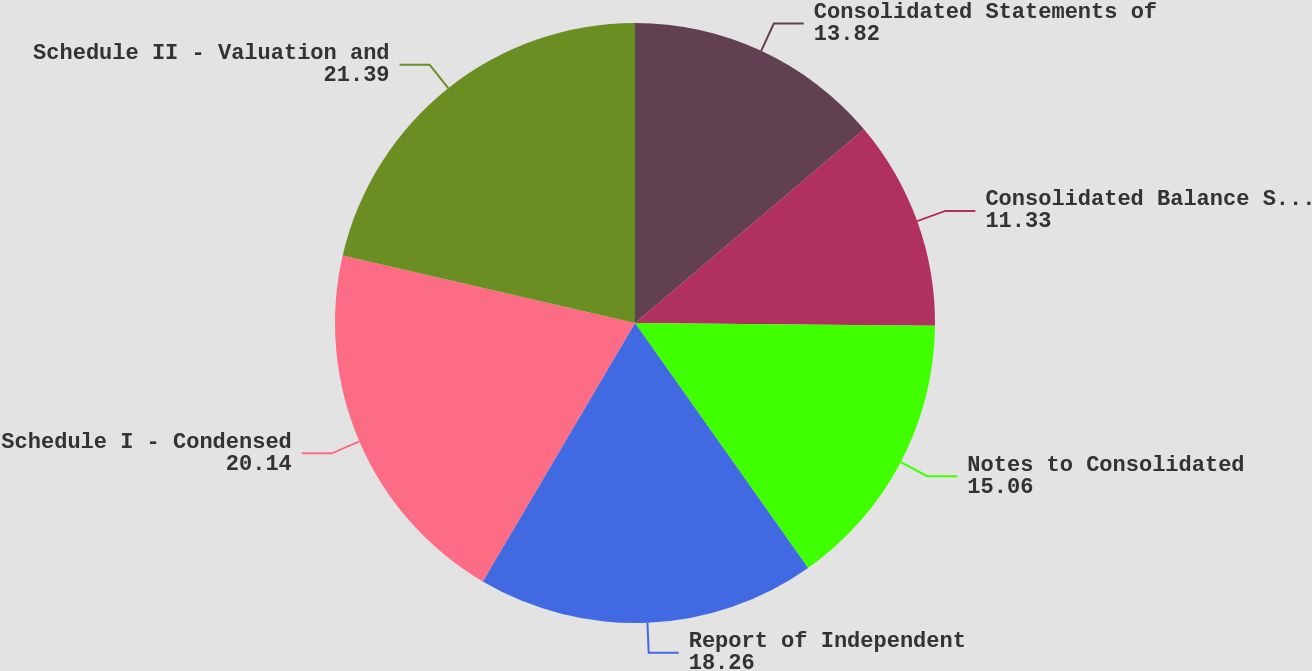Convert chart. <chart><loc_0><loc_0><loc_500><loc_500><pie_chart><fcel>Consolidated Statements of<fcel>Consolidated Balance Sheets<fcel>Notes to Consolidated<fcel>Report of Independent<fcel>Schedule I - Condensed<fcel>Schedule II - Valuation and<nl><fcel>13.82%<fcel>11.33%<fcel>15.06%<fcel>18.26%<fcel>20.14%<fcel>21.39%<nl></chart> 